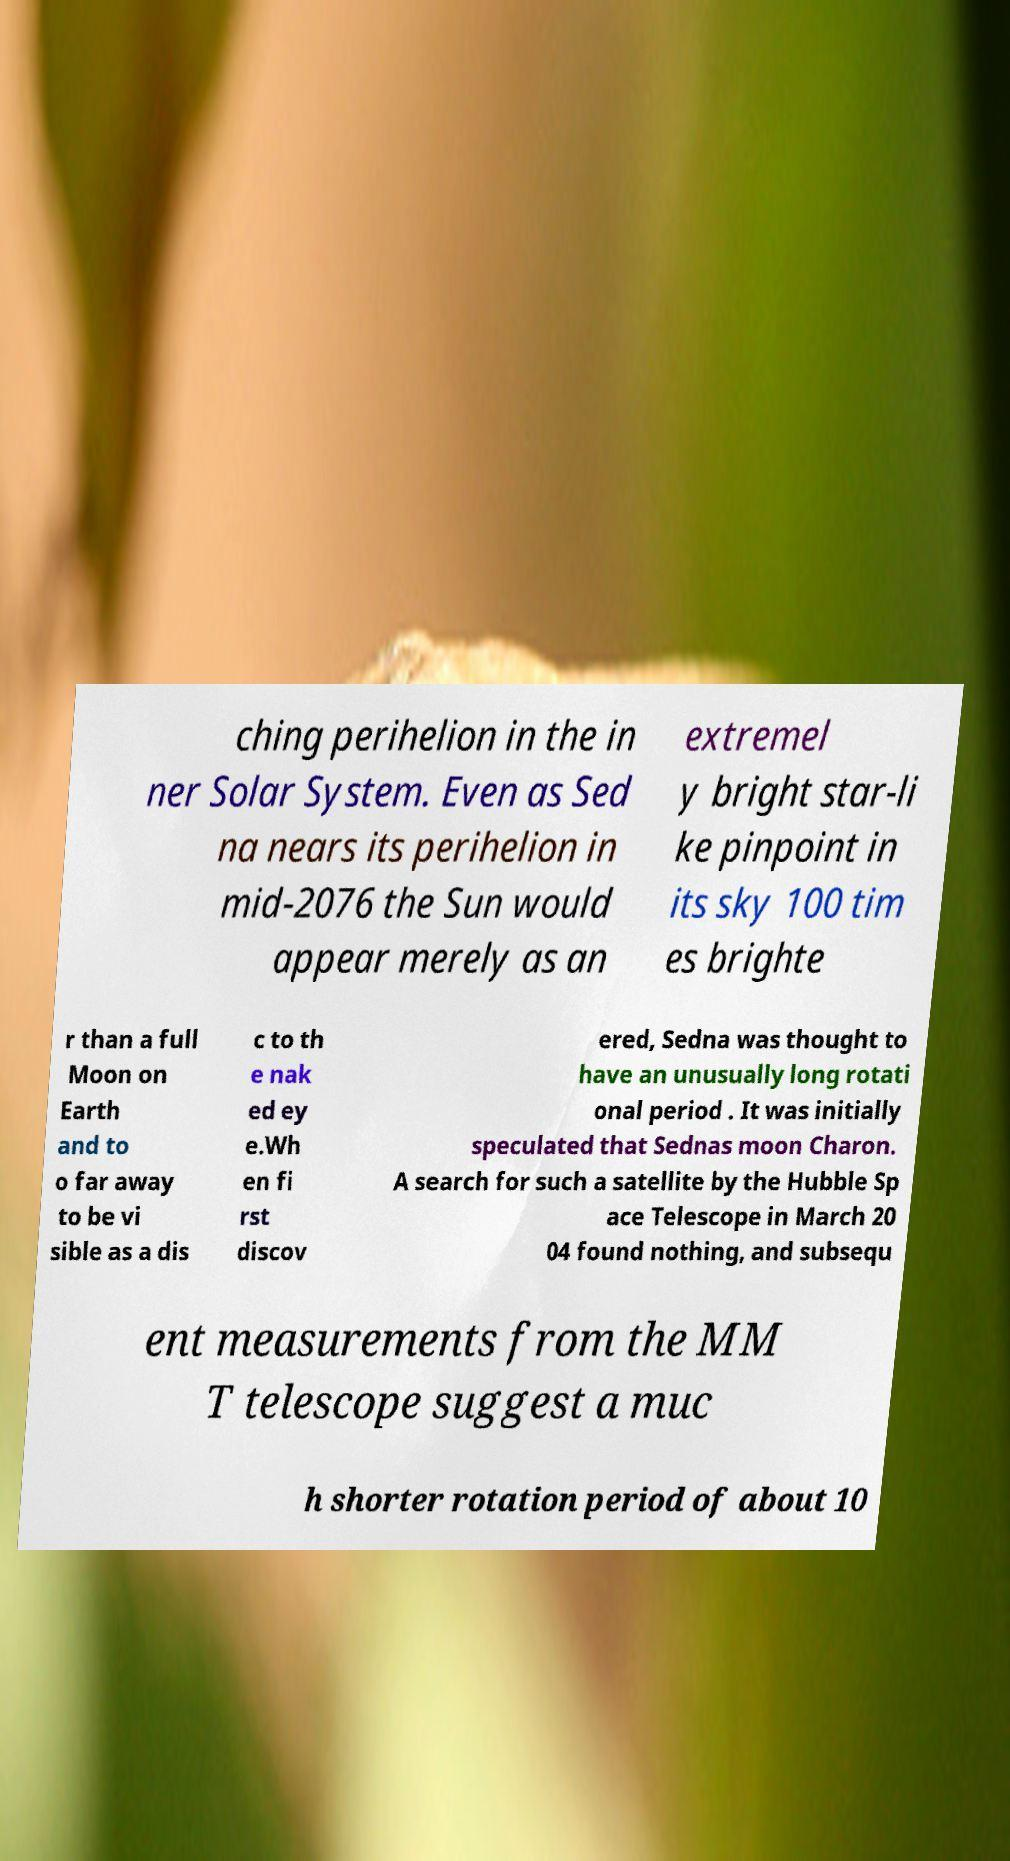Please read and relay the text visible in this image. What does it say? ching perihelion in the in ner Solar System. Even as Sed na nears its perihelion in mid-2076 the Sun would appear merely as an extremel y bright star-li ke pinpoint in its sky 100 tim es brighte r than a full Moon on Earth and to o far away to be vi sible as a dis c to th e nak ed ey e.Wh en fi rst discov ered, Sedna was thought to have an unusually long rotati onal period . It was initially speculated that Sednas moon Charon. A search for such a satellite by the Hubble Sp ace Telescope in March 20 04 found nothing, and subsequ ent measurements from the MM T telescope suggest a muc h shorter rotation period of about 10 